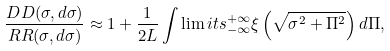Convert formula to latex. <formula><loc_0><loc_0><loc_500><loc_500>\frac { D D ( \sigma , d \sigma ) } { R R ( \sigma , d \sigma ) } \approx 1 + \frac { 1 } { 2 L } \int \lim i t s _ { - \infty } ^ { + \infty } \xi \left ( \sqrt { \sigma ^ { 2 } + \Pi ^ { 2 } } \right ) d \Pi ,</formula> 